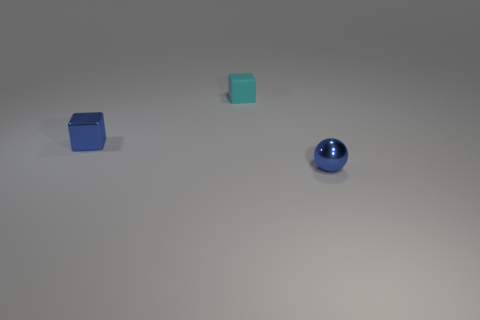Add 3 cyan objects. How many objects exist? 6 Subtract all balls. How many objects are left? 2 Subtract all small cyan rubber blocks. Subtract all blue metal objects. How many objects are left? 0 Add 3 cyan matte blocks. How many cyan matte blocks are left? 4 Add 1 small red shiny cubes. How many small red shiny cubes exist? 1 Subtract 0 brown spheres. How many objects are left? 3 Subtract all gray cubes. Subtract all purple balls. How many cubes are left? 2 